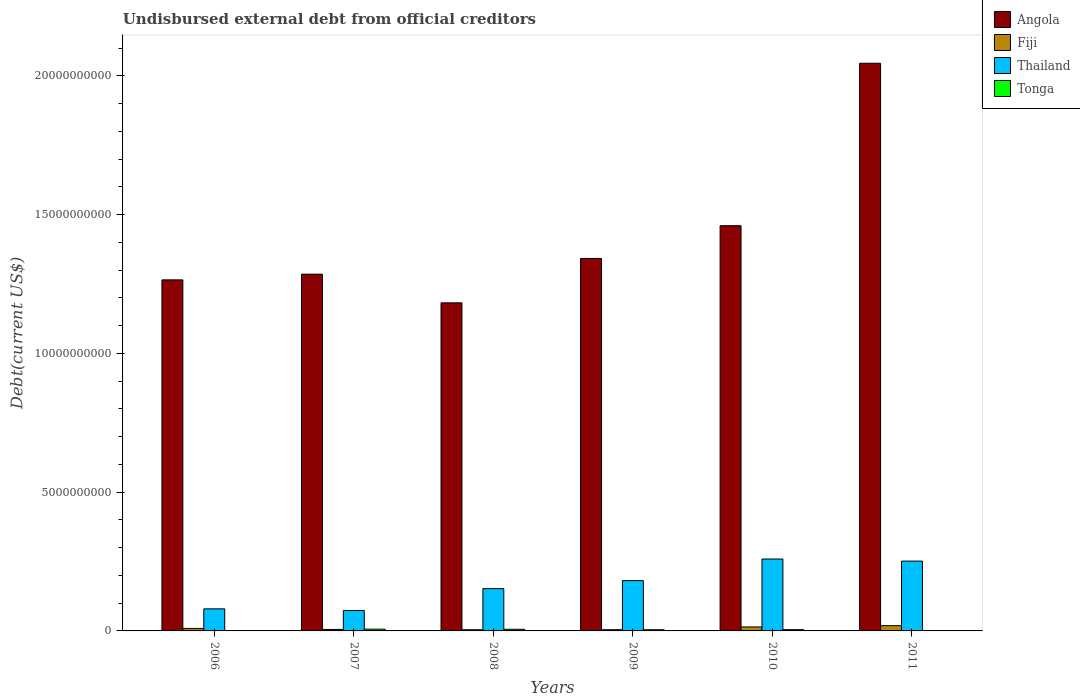How many different coloured bars are there?
Keep it short and to the point. 4. Are the number of bars per tick equal to the number of legend labels?
Offer a terse response. Yes. Are the number of bars on each tick of the X-axis equal?
Your response must be concise. Yes. How many bars are there on the 5th tick from the left?
Ensure brevity in your answer.  4. In how many cases, is the number of bars for a given year not equal to the number of legend labels?
Keep it short and to the point. 0. What is the total debt in Angola in 2010?
Keep it short and to the point. 1.46e+1. Across all years, what is the maximum total debt in Angola?
Your answer should be compact. 2.05e+1. Across all years, what is the minimum total debt in Fiji?
Offer a terse response. 4.18e+07. What is the total total debt in Angola in the graph?
Your answer should be compact. 8.58e+1. What is the difference between the total debt in Fiji in 2006 and that in 2007?
Keep it short and to the point. 3.64e+07. What is the difference between the total debt in Tonga in 2008 and the total debt in Angola in 2009?
Provide a succinct answer. -1.34e+1. What is the average total debt in Fiji per year?
Give a very brief answer. 9.39e+07. In the year 2007, what is the difference between the total debt in Fiji and total debt in Angola?
Provide a succinct answer. -1.28e+1. In how many years, is the total debt in Angola greater than 2000000000 US$?
Your answer should be very brief. 6. What is the ratio of the total debt in Tonga in 2006 to that in 2008?
Provide a succinct answer. 0.14. Is the total debt in Tonga in 2006 less than that in 2008?
Offer a very short reply. Yes. Is the difference between the total debt in Fiji in 2006 and 2011 greater than the difference between the total debt in Angola in 2006 and 2011?
Ensure brevity in your answer.  Yes. What is the difference between the highest and the second highest total debt in Tonga?
Give a very brief answer. 5.24e+06. What is the difference between the highest and the lowest total debt in Tonga?
Offer a terse response. 5.61e+07. In how many years, is the total debt in Thailand greater than the average total debt in Thailand taken over all years?
Your answer should be very brief. 3. What does the 1st bar from the left in 2007 represents?
Make the answer very short. Angola. What does the 3rd bar from the right in 2007 represents?
Offer a very short reply. Fiji. How many bars are there?
Your answer should be compact. 24. Are all the bars in the graph horizontal?
Give a very brief answer. No. How many years are there in the graph?
Keep it short and to the point. 6. Does the graph contain any zero values?
Make the answer very short. No. Does the graph contain grids?
Your answer should be compact. No. What is the title of the graph?
Make the answer very short. Undisbursed external debt from official creditors. Does "Heavily indebted poor countries" appear as one of the legend labels in the graph?
Give a very brief answer. No. What is the label or title of the X-axis?
Your response must be concise. Years. What is the label or title of the Y-axis?
Give a very brief answer. Debt(current US$). What is the Debt(current US$) of Angola in 2006?
Your answer should be very brief. 1.27e+1. What is the Debt(current US$) in Fiji in 2006?
Offer a very short reply. 9.00e+07. What is the Debt(current US$) in Thailand in 2006?
Provide a succinct answer. 7.96e+08. What is the Debt(current US$) of Tonga in 2006?
Offer a terse response. 8.28e+06. What is the Debt(current US$) in Angola in 2007?
Your answer should be very brief. 1.29e+1. What is the Debt(current US$) in Fiji in 2007?
Offer a terse response. 5.36e+07. What is the Debt(current US$) in Thailand in 2007?
Your answer should be very brief. 7.37e+08. What is the Debt(current US$) of Tonga in 2007?
Make the answer very short. 6.43e+07. What is the Debt(current US$) of Angola in 2008?
Provide a succinct answer. 1.18e+1. What is the Debt(current US$) of Fiji in 2008?
Your answer should be very brief. 4.18e+07. What is the Debt(current US$) of Thailand in 2008?
Your response must be concise. 1.52e+09. What is the Debt(current US$) of Tonga in 2008?
Your answer should be compact. 5.91e+07. What is the Debt(current US$) in Angola in 2009?
Provide a short and direct response. 1.34e+1. What is the Debt(current US$) in Fiji in 2009?
Give a very brief answer. 4.44e+07. What is the Debt(current US$) of Thailand in 2009?
Provide a succinct answer. 1.81e+09. What is the Debt(current US$) in Tonga in 2009?
Make the answer very short. 4.25e+07. What is the Debt(current US$) of Angola in 2010?
Your response must be concise. 1.46e+1. What is the Debt(current US$) of Fiji in 2010?
Keep it short and to the point. 1.44e+08. What is the Debt(current US$) in Thailand in 2010?
Your answer should be compact. 2.59e+09. What is the Debt(current US$) of Tonga in 2010?
Keep it short and to the point. 4.62e+07. What is the Debt(current US$) in Angola in 2011?
Your answer should be compact. 2.05e+1. What is the Debt(current US$) in Fiji in 2011?
Give a very brief answer. 1.90e+08. What is the Debt(current US$) in Thailand in 2011?
Offer a terse response. 2.52e+09. What is the Debt(current US$) in Tonga in 2011?
Ensure brevity in your answer.  1.12e+07. Across all years, what is the maximum Debt(current US$) in Angola?
Your answer should be very brief. 2.05e+1. Across all years, what is the maximum Debt(current US$) in Fiji?
Provide a short and direct response. 1.90e+08. Across all years, what is the maximum Debt(current US$) of Thailand?
Ensure brevity in your answer.  2.59e+09. Across all years, what is the maximum Debt(current US$) of Tonga?
Provide a succinct answer. 6.43e+07. Across all years, what is the minimum Debt(current US$) in Angola?
Your response must be concise. 1.18e+1. Across all years, what is the minimum Debt(current US$) in Fiji?
Provide a succinct answer. 4.18e+07. Across all years, what is the minimum Debt(current US$) in Thailand?
Your answer should be compact. 7.37e+08. Across all years, what is the minimum Debt(current US$) of Tonga?
Your answer should be very brief. 8.28e+06. What is the total Debt(current US$) in Angola in the graph?
Offer a very short reply. 8.58e+1. What is the total Debt(current US$) of Fiji in the graph?
Offer a terse response. 5.63e+08. What is the total Debt(current US$) in Thailand in the graph?
Keep it short and to the point. 9.98e+09. What is the total Debt(current US$) in Tonga in the graph?
Your answer should be very brief. 2.32e+08. What is the difference between the Debt(current US$) of Angola in 2006 and that in 2007?
Your answer should be very brief. -2.05e+08. What is the difference between the Debt(current US$) in Fiji in 2006 and that in 2007?
Provide a short and direct response. 3.64e+07. What is the difference between the Debt(current US$) in Thailand in 2006 and that in 2007?
Your response must be concise. 5.87e+07. What is the difference between the Debt(current US$) of Tonga in 2006 and that in 2007?
Make the answer very short. -5.61e+07. What is the difference between the Debt(current US$) of Angola in 2006 and that in 2008?
Provide a succinct answer. 8.28e+08. What is the difference between the Debt(current US$) in Fiji in 2006 and that in 2008?
Your answer should be very brief. 4.82e+07. What is the difference between the Debt(current US$) of Thailand in 2006 and that in 2008?
Provide a succinct answer. -7.29e+08. What is the difference between the Debt(current US$) in Tonga in 2006 and that in 2008?
Offer a very short reply. -5.08e+07. What is the difference between the Debt(current US$) in Angola in 2006 and that in 2009?
Your answer should be compact. -7.71e+08. What is the difference between the Debt(current US$) in Fiji in 2006 and that in 2009?
Make the answer very short. 4.56e+07. What is the difference between the Debt(current US$) of Thailand in 2006 and that in 2009?
Offer a terse response. -1.02e+09. What is the difference between the Debt(current US$) in Tonga in 2006 and that in 2009?
Your answer should be very brief. -3.42e+07. What is the difference between the Debt(current US$) in Angola in 2006 and that in 2010?
Keep it short and to the point. -1.95e+09. What is the difference between the Debt(current US$) of Fiji in 2006 and that in 2010?
Ensure brevity in your answer.  -5.38e+07. What is the difference between the Debt(current US$) in Thailand in 2006 and that in 2010?
Offer a terse response. -1.80e+09. What is the difference between the Debt(current US$) in Tonga in 2006 and that in 2010?
Give a very brief answer. -3.79e+07. What is the difference between the Debt(current US$) of Angola in 2006 and that in 2011?
Offer a very short reply. -7.81e+09. What is the difference between the Debt(current US$) in Fiji in 2006 and that in 2011?
Ensure brevity in your answer.  -9.98e+07. What is the difference between the Debt(current US$) of Thailand in 2006 and that in 2011?
Make the answer very short. -1.72e+09. What is the difference between the Debt(current US$) of Tonga in 2006 and that in 2011?
Give a very brief answer. -2.92e+06. What is the difference between the Debt(current US$) of Angola in 2007 and that in 2008?
Give a very brief answer. 1.03e+09. What is the difference between the Debt(current US$) of Fiji in 2007 and that in 2008?
Provide a succinct answer. 1.18e+07. What is the difference between the Debt(current US$) in Thailand in 2007 and that in 2008?
Offer a very short reply. -7.87e+08. What is the difference between the Debt(current US$) in Tonga in 2007 and that in 2008?
Provide a succinct answer. 5.24e+06. What is the difference between the Debt(current US$) in Angola in 2007 and that in 2009?
Keep it short and to the point. -5.66e+08. What is the difference between the Debt(current US$) of Fiji in 2007 and that in 2009?
Offer a very short reply. 9.20e+06. What is the difference between the Debt(current US$) in Thailand in 2007 and that in 2009?
Your answer should be compact. -1.08e+09. What is the difference between the Debt(current US$) of Tonga in 2007 and that in 2009?
Give a very brief answer. 2.18e+07. What is the difference between the Debt(current US$) in Angola in 2007 and that in 2010?
Provide a succinct answer. -1.75e+09. What is the difference between the Debt(current US$) in Fiji in 2007 and that in 2010?
Offer a terse response. -9.02e+07. What is the difference between the Debt(current US$) of Thailand in 2007 and that in 2010?
Your response must be concise. -1.85e+09. What is the difference between the Debt(current US$) in Tonga in 2007 and that in 2010?
Give a very brief answer. 1.81e+07. What is the difference between the Debt(current US$) of Angola in 2007 and that in 2011?
Give a very brief answer. -7.60e+09. What is the difference between the Debt(current US$) in Fiji in 2007 and that in 2011?
Keep it short and to the point. -1.36e+08. What is the difference between the Debt(current US$) in Thailand in 2007 and that in 2011?
Offer a very short reply. -1.78e+09. What is the difference between the Debt(current US$) of Tonga in 2007 and that in 2011?
Provide a short and direct response. 5.31e+07. What is the difference between the Debt(current US$) in Angola in 2008 and that in 2009?
Provide a short and direct response. -1.60e+09. What is the difference between the Debt(current US$) in Fiji in 2008 and that in 2009?
Offer a very short reply. -2.61e+06. What is the difference between the Debt(current US$) in Thailand in 2008 and that in 2009?
Provide a succinct answer. -2.89e+08. What is the difference between the Debt(current US$) in Tonga in 2008 and that in 2009?
Provide a short and direct response. 1.66e+07. What is the difference between the Debt(current US$) in Angola in 2008 and that in 2010?
Offer a very short reply. -2.78e+09. What is the difference between the Debt(current US$) of Fiji in 2008 and that in 2010?
Your answer should be very brief. -1.02e+08. What is the difference between the Debt(current US$) in Thailand in 2008 and that in 2010?
Offer a very short reply. -1.07e+09. What is the difference between the Debt(current US$) of Tonga in 2008 and that in 2010?
Your answer should be compact. 1.29e+07. What is the difference between the Debt(current US$) in Angola in 2008 and that in 2011?
Keep it short and to the point. -8.63e+09. What is the difference between the Debt(current US$) in Fiji in 2008 and that in 2011?
Provide a succinct answer. -1.48e+08. What is the difference between the Debt(current US$) of Thailand in 2008 and that in 2011?
Offer a very short reply. -9.92e+08. What is the difference between the Debt(current US$) in Tonga in 2008 and that in 2011?
Provide a short and direct response. 4.79e+07. What is the difference between the Debt(current US$) in Angola in 2009 and that in 2010?
Ensure brevity in your answer.  -1.18e+09. What is the difference between the Debt(current US$) of Fiji in 2009 and that in 2010?
Ensure brevity in your answer.  -9.94e+07. What is the difference between the Debt(current US$) of Thailand in 2009 and that in 2010?
Provide a succinct answer. -7.78e+08. What is the difference between the Debt(current US$) of Tonga in 2009 and that in 2010?
Your answer should be very brief. -3.69e+06. What is the difference between the Debt(current US$) in Angola in 2009 and that in 2011?
Provide a short and direct response. -7.03e+09. What is the difference between the Debt(current US$) of Fiji in 2009 and that in 2011?
Make the answer very short. -1.45e+08. What is the difference between the Debt(current US$) in Thailand in 2009 and that in 2011?
Make the answer very short. -7.03e+08. What is the difference between the Debt(current US$) in Tonga in 2009 and that in 2011?
Your answer should be compact. 3.13e+07. What is the difference between the Debt(current US$) of Angola in 2010 and that in 2011?
Provide a short and direct response. -5.85e+09. What is the difference between the Debt(current US$) in Fiji in 2010 and that in 2011?
Your response must be concise. -4.60e+07. What is the difference between the Debt(current US$) in Thailand in 2010 and that in 2011?
Your response must be concise. 7.56e+07. What is the difference between the Debt(current US$) in Tonga in 2010 and that in 2011?
Your answer should be compact. 3.50e+07. What is the difference between the Debt(current US$) of Angola in 2006 and the Debt(current US$) of Fiji in 2007?
Your answer should be compact. 1.26e+1. What is the difference between the Debt(current US$) in Angola in 2006 and the Debt(current US$) in Thailand in 2007?
Keep it short and to the point. 1.19e+1. What is the difference between the Debt(current US$) of Angola in 2006 and the Debt(current US$) of Tonga in 2007?
Keep it short and to the point. 1.26e+1. What is the difference between the Debt(current US$) of Fiji in 2006 and the Debt(current US$) of Thailand in 2007?
Offer a very short reply. -6.47e+08. What is the difference between the Debt(current US$) in Fiji in 2006 and the Debt(current US$) in Tonga in 2007?
Offer a terse response. 2.56e+07. What is the difference between the Debt(current US$) of Thailand in 2006 and the Debt(current US$) of Tonga in 2007?
Give a very brief answer. 7.31e+08. What is the difference between the Debt(current US$) in Angola in 2006 and the Debt(current US$) in Fiji in 2008?
Keep it short and to the point. 1.26e+1. What is the difference between the Debt(current US$) of Angola in 2006 and the Debt(current US$) of Thailand in 2008?
Offer a terse response. 1.11e+1. What is the difference between the Debt(current US$) in Angola in 2006 and the Debt(current US$) in Tonga in 2008?
Your answer should be compact. 1.26e+1. What is the difference between the Debt(current US$) of Fiji in 2006 and the Debt(current US$) of Thailand in 2008?
Keep it short and to the point. -1.43e+09. What is the difference between the Debt(current US$) in Fiji in 2006 and the Debt(current US$) in Tonga in 2008?
Provide a succinct answer. 3.09e+07. What is the difference between the Debt(current US$) in Thailand in 2006 and the Debt(current US$) in Tonga in 2008?
Provide a short and direct response. 7.36e+08. What is the difference between the Debt(current US$) in Angola in 2006 and the Debt(current US$) in Fiji in 2009?
Provide a short and direct response. 1.26e+1. What is the difference between the Debt(current US$) in Angola in 2006 and the Debt(current US$) in Thailand in 2009?
Give a very brief answer. 1.08e+1. What is the difference between the Debt(current US$) of Angola in 2006 and the Debt(current US$) of Tonga in 2009?
Keep it short and to the point. 1.26e+1. What is the difference between the Debt(current US$) of Fiji in 2006 and the Debt(current US$) of Thailand in 2009?
Ensure brevity in your answer.  -1.72e+09. What is the difference between the Debt(current US$) of Fiji in 2006 and the Debt(current US$) of Tonga in 2009?
Offer a terse response. 4.75e+07. What is the difference between the Debt(current US$) in Thailand in 2006 and the Debt(current US$) in Tonga in 2009?
Offer a terse response. 7.53e+08. What is the difference between the Debt(current US$) in Angola in 2006 and the Debt(current US$) in Fiji in 2010?
Offer a very short reply. 1.25e+1. What is the difference between the Debt(current US$) in Angola in 2006 and the Debt(current US$) in Thailand in 2010?
Ensure brevity in your answer.  1.01e+1. What is the difference between the Debt(current US$) in Angola in 2006 and the Debt(current US$) in Tonga in 2010?
Give a very brief answer. 1.26e+1. What is the difference between the Debt(current US$) in Fiji in 2006 and the Debt(current US$) in Thailand in 2010?
Give a very brief answer. -2.50e+09. What is the difference between the Debt(current US$) of Fiji in 2006 and the Debt(current US$) of Tonga in 2010?
Offer a terse response. 4.38e+07. What is the difference between the Debt(current US$) in Thailand in 2006 and the Debt(current US$) in Tonga in 2010?
Provide a short and direct response. 7.49e+08. What is the difference between the Debt(current US$) in Angola in 2006 and the Debt(current US$) in Fiji in 2011?
Offer a terse response. 1.25e+1. What is the difference between the Debt(current US$) in Angola in 2006 and the Debt(current US$) in Thailand in 2011?
Provide a short and direct response. 1.01e+1. What is the difference between the Debt(current US$) in Angola in 2006 and the Debt(current US$) in Tonga in 2011?
Offer a very short reply. 1.26e+1. What is the difference between the Debt(current US$) of Fiji in 2006 and the Debt(current US$) of Thailand in 2011?
Provide a short and direct response. -2.43e+09. What is the difference between the Debt(current US$) in Fiji in 2006 and the Debt(current US$) in Tonga in 2011?
Keep it short and to the point. 7.88e+07. What is the difference between the Debt(current US$) in Thailand in 2006 and the Debt(current US$) in Tonga in 2011?
Make the answer very short. 7.84e+08. What is the difference between the Debt(current US$) in Angola in 2007 and the Debt(current US$) in Fiji in 2008?
Your answer should be very brief. 1.28e+1. What is the difference between the Debt(current US$) of Angola in 2007 and the Debt(current US$) of Thailand in 2008?
Make the answer very short. 1.13e+1. What is the difference between the Debt(current US$) in Angola in 2007 and the Debt(current US$) in Tonga in 2008?
Keep it short and to the point. 1.28e+1. What is the difference between the Debt(current US$) in Fiji in 2007 and the Debt(current US$) in Thailand in 2008?
Offer a terse response. -1.47e+09. What is the difference between the Debt(current US$) of Fiji in 2007 and the Debt(current US$) of Tonga in 2008?
Your response must be concise. -5.51e+06. What is the difference between the Debt(current US$) in Thailand in 2007 and the Debt(current US$) in Tonga in 2008?
Provide a succinct answer. 6.78e+08. What is the difference between the Debt(current US$) of Angola in 2007 and the Debt(current US$) of Fiji in 2009?
Offer a very short reply. 1.28e+1. What is the difference between the Debt(current US$) in Angola in 2007 and the Debt(current US$) in Thailand in 2009?
Ensure brevity in your answer.  1.10e+1. What is the difference between the Debt(current US$) of Angola in 2007 and the Debt(current US$) of Tonga in 2009?
Your response must be concise. 1.28e+1. What is the difference between the Debt(current US$) of Fiji in 2007 and the Debt(current US$) of Thailand in 2009?
Provide a succinct answer. -1.76e+09. What is the difference between the Debt(current US$) of Fiji in 2007 and the Debt(current US$) of Tonga in 2009?
Keep it short and to the point. 1.11e+07. What is the difference between the Debt(current US$) in Thailand in 2007 and the Debt(current US$) in Tonga in 2009?
Your response must be concise. 6.94e+08. What is the difference between the Debt(current US$) in Angola in 2007 and the Debt(current US$) in Fiji in 2010?
Your answer should be very brief. 1.27e+1. What is the difference between the Debt(current US$) in Angola in 2007 and the Debt(current US$) in Thailand in 2010?
Give a very brief answer. 1.03e+1. What is the difference between the Debt(current US$) of Angola in 2007 and the Debt(current US$) of Tonga in 2010?
Your response must be concise. 1.28e+1. What is the difference between the Debt(current US$) of Fiji in 2007 and the Debt(current US$) of Thailand in 2010?
Give a very brief answer. -2.54e+09. What is the difference between the Debt(current US$) of Fiji in 2007 and the Debt(current US$) of Tonga in 2010?
Provide a succinct answer. 7.37e+06. What is the difference between the Debt(current US$) in Thailand in 2007 and the Debt(current US$) in Tonga in 2010?
Keep it short and to the point. 6.91e+08. What is the difference between the Debt(current US$) of Angola in 2007 and the Debt(current US$) of Fiji in 2011?
Your answer should be very brief. 1.27e+1. What is the difference between the Debt(current US$) in Angola in 2007 and the Debt(current US$) in Thailand in 2011?
Provide a succinct answer. 1.03e+1. What is the difference between the Debt(current US$) in Angola in 2007 and the Debt(current US$) in Tonga in 2011?
Offer a very short reply. 1.28e+1. What is the difference between the Debt(current US$) of Fiji in 2007 and the Debt(current US$) of Thailand in 2011?
Provide a succinct answer. -2.46e+09. What is the difference between the Debt(current US$) in Fiji in 2007 and the Debt(current US$) in Tonga in 2011?
Provide a succinct answer. 4.24e+07. What is the difference between the Debt(current US$) in Thailand in 2007 and the Debt(current US$) in Tonga in 2011?
Ensure brevity in your answer.  7.26e+08. What is the difference between the Debt(current US$) of Angola in 2008 and the Debt(current US$) of Fiji in 2009?
Offer a very short reply. 1.18e+1. What is the difference between the Debt(current US$) in Angola in 2008 and the Debt(current US$) in Thailand in 2009?
Ensure brevity in your answer.  1.00e+1. What is the difference between the Debt(current US$) of Angola in 2008 and the Debt(current US$) of Tonga in 2009?
Ensure brevity in your answer.  1.18e+1. What is the difference between the Debt(current US$) in Fiji in 2008 and the Debt(current US$) in Thailand in 2009?
Keep it short and to the point. -1.77e+09. What is the difference between the Debt(current US$) in Fiji in 2008 and the Debt(current US$) in Tonga in 2009?
Your answer should be compact. -7.49e+05. What is the difference between the Debt(current US$) of Thailand in 2008 and the Debt(current US$) of Tonga in 2009?
Keep it short and to the point. 1.48e+09. What is the difference between the Debt(current US$) of Angola in 2008 and the Debt(current US$) of Fiji in 2010?
Offer a very short reply. 1.17e+1. What is the difference between the Debt(current US$) in Angola in 2008 and the Debt(current US$) in Thailand in 2010?
Keep it short and to the point. 9.23e+09. What is the difference between the Debt(current US$) of Angola in 2008 and the Debt(current US$) of Tonga in 2010?
Make the answer very short. 1.18e+1. What is the difference between the Debt(current US$) of Fiji in 2008 and the Debt(current US$) of Thailand in 2010?
Your answer should be compact. -2.55e+09. What is the difference between the Debt(current US$) in Fiji in 2008 and the Debt(current US$) in Tonga in 2010?
Give a very brief answer. -4.44e+06. What is the difference between the Debt(current US$) in Thailand in 2008 and the Debt(current US$) in Tonga in 2010?
Keep it short and to the point. 1.48e+09. What is the difference between the Debt(current US$) in Angola in 2008 and the Debt(current US$) in Fiji in 2011?
Your answer should be very brief. 1.16e+1. What is the difference between the Debt(current US$) in Angola in 2008 and the Debt(current US$) in Thailand in 2011?
Offer a very short reply. 9.31e+09. What is the difference between the Debt(current US$) in Angola in 2008 and the Debt(current US$) in Tonga in 2011?
Ensure brevity in your answer.  1.18e+1. What is the difference between the Debt(current US$) in Fiji in 2008 and the Debt(current US$) in Thailand in 2011?
Your answer should be compact. -2.47e+09. What is the difference between the Debt(current US$) in Fiji in 2008 and the Debt(current US$) in Tonga in 2011?
Offer a terse response. 3.06e+07. What is the difference between the Debt(current US$) in Thailand in 2008 and the Debt(current US$) in Tonga in 2011?
Give a very brief answer. 1.51e+09. What is the difference between the Debt(current US$) of Angola in 2009 and the Debt(current US$) of Fiji in 2010?
Offer a terse response. 1.33e+1. What is the difference between the Debt(current US$) in Angola in 2009 and the Debt(current US$) in Thailand in 2010?
Offer a terse response. 1.08e+1. What is the difference between the Debt(current US$) of Angola in 2009 and the Debt(current US$) of Tonga in 2010?
Your answer should be very brief. 1.34e+1. What is the difference between the Debt(current US$) in Fiji in 2009 and the Debt(current US$) in Thailand in 2010?
Ensure brevity in your answer.  -2.55e+09. What is the difference between the Debt(current US$) in Fiji in 2009 and the Debt(current US$) in Tonga in 2010?
Ensure brevity in your answer.  -1.83e+06. What is the difference between the Debt(current US$) in Thailand in 2009 and the Debt(current US$) in Tonga in 2010?
Your answer should be compact. 1.77e+09. What is the difference between the Debt(current US$) in Angola in 2009 and the Debt(current US$) in Fiji in 2011?
Your response must be concise. 1.32e+1. What is the difference between the Debt(current US$) of Angola in 2009 and the Debt(current US$) of Thailand in 2011?
Ensure brevity in your answer.  1.09e+1. What is the difference between the Debt(current US$) in Angola in 2009 and the Debt(current US$) in Tonga in 2011?
Offer a very short reply. 1.34e+1. What is the difference between the Debt(current US$) of Fiji in 2009 and the Debt(current US$) of Thailand in 2011?
Provide a short and direct response. -2.47e+09. What is the difference between the Debt(current US$) in Fiji in 2009 and the Debt(current US$) in Tonga in 2011?
Ensure brevity in your answer.  3.32e+07. What is the difference between the Debt(current US$) of Thailand in 2009 and the Debt(current US$) of Tonga in 2011?
Your answer should be very brief. 1.80e+09. What is the difference between the Debt(current US$) in Angola in 2010 and the Debt(current US$) in Fiji in 2011?
Ensure brevity in your answer.  1.44e+1. What is the difference between the Debt(current US$) of Angola in 2010 and the Debt(current US$) of Thailand in 2011?
Give a very brief answer. 1.21e+1. What is the difference between the Debt(current US$) in Angola in 2010 and the Debt(current US$) in Tonga in 2011?
Make the answer very short. 1.46e+1. What is the difference between the Debt(current US$) of Fiji in 2010 and the Debt(current US$) of Thailand in 2011?
Offer a terse response. -2.37e+09. What is the difference between the Debt(current US$) in Fiji in 2010 and the Debt(current US$) in Tonga in 2011?
Give a very brief answer. 1.33e+08. What is the difference between the Debt(current US$) of Thailand in 2010 and the Debt(current US$) of Tonga in 2011?
Your answer should be compact. 2.58e+09. What is the average Debt(current US$) of Angola per year?
Make the answer very short. 1.43e+1. What is the average Debt(current US$) in Fiji per year?
Provide a succinct answer. 9.39e+07. What is the average Debt(current US$) of Thailand per year?
Provide a short and direct response. 1.66e+09. What is the average Debt(current US$) of Tonga per year?
Your answer should be very brief. 3.86e+07. In the year 2006, what is the difference between the Debt(current US$) in Angola and Debt(current US$) in Fiji?
Offer a very short reply. 1.26e+1. In the year 2006, what is the difference between the Debt(current US$) of Angola and Debt(current US$) of Thailand?
Make the answer very short. 1.19e+1. In the year 2006, what is the difference between the Debt(current US$) in Angola and Debt(current US$) in Tonga?
Your response must be concise. 1.26e+1. In the year 2006, what is the difference between the Debt(current US$) in Fiji and Debt(current US$) in Thailand?
Ensure brevity in your answer.  -7.06e+08. In the year 2006, what is the difference between the Debt(current US$) of Fiji and Debt(current US$) of Tonga?
Your response must be concise. 8.17e+07. In the year 2006, what is the difference between the Debt(current US$) in Thailand and Debt(current US$) in Tonga?
Your answer should be compact. 7.87e+08. In the year 2007, what is the difference between the Debt(current US$) in Angola and Debt(current US$) in Fiji?
Provide a succinct answer. 1.28e+1. In the year 2007, what is the difference between the Debt(current US$) of Angola and Debt(current US$) of Thailand?
Ensure brevity in your answer.  1.21e+1. In the year 2007, what is the difference between the Debt(current US$) in Angola and Debt(current US$) in Tonga?
Provide a succinct answer. 1.28e+1. In the year 2007, what is the difference between the Debt(current US$) in Fiji and Debt(current US$) in Thailand?
Your response must be concise. -6.83e+08. In the year 2007, what is the difference between the Debt(current US$) in Fiji and Debt(current US$) in Tonga?
Provide a succinct answer. -1.08e+07. In the year 2007, what is the difference between the Debt(current US$) of Thailand and Debt(current US$) of Tonga?
Your response must be concise. 6.73e+08. In the year 2008, what is the difference between the Debt(current US$) of Angola and Debt(current US$) of Fiji?
Make the answer very short. 1.18e+1. In the year 2008, what is the difference between the Debt(current US$) of Angola and Debt(current US$) of Thailand?
Provide a succinct answer. 1.03e+1. In the year 2008, what is the difference between the Debt(current US$) of Angola and Debt(current US$) of Tonga?
Offer a very short reply. 1.18e+1. In the year 2008, what is the difference between the Debt(current US$) of Fiji and Debt(current US$) of Thailand?
Offer a terse response. -1.48e+09. In the year 2008, what is the difference between the Debt(current US$) of Fiji and Debt(current US$) of Tonga?
Provide a short and direct response. -1.73e+07. In the year 2008, what is the difference between the Debt(current US$) of Thailand and Debt(current US$) of Tonga?
Offer a terse response. 1.47e+09. In the year 2009, what is the difference between the Debt(current US$) in Angola and Debt(current US$) in Fiji?
Provide a succinct answer. 1.34e+1. In the year 2009, what is the difference between the Debt(current US$) in Angola and Debt(current US$) in Thailand?
Your answer should be compact. 1.16e+1. In the year 2009, what is the difference between the Debt(current US$) in Angola and Debt(current US$) in Tonga?
Your answer should be very brief. 1.34e+1. In the year 2009, what is the difference between the Debt(current US$) in Fiji and Debt(current US$) in Thailand?
Provide a succinct answer. -1.77e+09. In the year 2009, what is the difference between the Debt(current US$) of Fiji and Debt(current US$) of Tonga?
Provide a short and direct response. 1.86e+06. In the year 2009, what is the difference between the Debt(current US$) of Thailand and Debt(current US$) of Tonga?
Provide a succinct answer. 1.77e+09. In the year 2010, what is the difference between the Debt(current US$) of Angola and Debt(current US$) of Fiji?
Give a very brief answer. 1.45e+1. In the year 2010, what is the difference between the Debt(current US$) of Angola and Debt(current US$) of Thailand?
Provide a short and direct response. 1.20e+1. In the year 2010, what is the difference between the Debt(current US$) of Angola and Debt(current US$) of Tonga?
Make the answer very short. 1.46e+1. In the year 2010, what is the difference between the Debt(current US$) in Fiji and Debt(current US$) in Thailand?
Keep it short and to the point. -2.45e+09. In the year 2010, what is the difference between the Debt(current US$) of Fiji and Debt(current US$) of Tonga?
Provide a short and direct response. 9.76e+07. In the year 2010, what is the difference between the Debt(current US$) in Thailand and Debt(current US$) in Tonga?
Your response must be concise. 2.55e+09. In the year 2011, what is the difference between the Debt(current US$) in Angola and Debt(current US$) in Fiji?
Provide a short and direct response. 2.03e+1. In the year 2011, what is the difference between the Debt(current US$) in Angola and Debt(current US$) in Thailand?
Offer a very short reply. 1.79e+1. In the year 2011, what is the difference between the Debt(current US$) in Angola and Debt(current US$) in Tonga?
Provide a short and direct response. 2.04e+1. In the year 2011, what is the difference between the Debt(current US$) of Fiji and Debt(current US$) of Thailand?
Provide a succinct answer. -2.33e+09. In the year 2011, what is the difference between the Debt(current US$) in Fiji and Debt(current US$) in Tonga?
Make the answer very short. 1.79e+08. In the year 2011, what is the difference between the Debt(current US$) of Thailand and Debt(current US$) of Tonga?
Your answer should be very brief. 2.50e+09. What is the ratio of the Debt(current US$) in Fiji in 2006 to that in 2007?
Your answer should be compact. 1.68. What is the ratio of the Debt(current US$) of Thailand in 2006 to that in 2007?
Your answer should be very brief. 1.08. What is the ratio of the Debt(current US$) in Tonga in 2006 to that in 2007?
Make the answer very short. 0.13. What is the ratio of the Debt(current US$) in Angola in 2006 to that in 2008?
Keep it short and to the point. 1.07. What is the ratio of the Debt(current US$) in Fiji in 2006 to that in 2008?
Your answer should be compact. 2.15. What is the ratio of the Debt(current US$) of Thailand in 2006 to that in 2008?
Offer a terse response. 0.52. What is the ratio of the Debt(current US$) in Tonga in 2006 to that in 2008?
Ensure brevity in your answer.  0.14. What is the ratio of the Debt(current US$) of Angola in 2006 to that in 2009?
Offer a terse response. 0.94. What is the ratio of the Debt(current US$) of Fiji in 2006 to that in 2009?
Make the answer very short. 2.03. What is the ratio of the Debt(current US$) in Thailand in 2006 to that in 2009?
Your response must be concise. 0.44. What is the ratio of the Debt(current US$) in Tonga in 2006 to that in 2009?
Your answer should be compact. 0.19. What is the ratio of the Debt(current US$) in Angola in 2006 to that in 2010?
Your answer should be compact. 0.87. What is the ratio of the Debt(current US$) of Fiji in 2006 to that in 2010?
Your answer should be compact. 0.63. What is the ratio of the Debt(current US$) in Thailand in 2006 to that in 2010?
Offer a terse response. 0.31. What is the ratio of the Debt(current US$) in Tonga in 2006 to that in 2010?
Make the answer very short. 0.18. What is the ratio of the Debt(current US$) of Angola in 2006 to that in 2011?
Ensure brevity in your answer.  0.62. What is the ratio of the Debt(current US$) in Fiji in 2006 to that in 2011?
Offer a very short reply. 0.47. What is the ratio of the Debt(current US$) of Thailand in 2006 to that in 2011?
Provide a succinct answer. 0.32. What is the ratio of the Debt(current US$) in Tonga in 2006 to that in 2011?
Ensure brevity in your answer.  0.74. What is the ratio of the Debt(current US$) of Angola in 2007 to that in 2008?
Ensure brevity in your answer.  1.09. What is the ratio of the Debt(current US$) in Fiji in 2007 to that in 2008?
Provide a short and direct response. 1.28. What is the ratio of the Debt(current US$) in Thailand in 2007 to that in 2008?
Make the answer very short. 0.48. What is the ratio of the Debt(current US$) of Tonga in 2007 to that in 2008?
Keep it short and to the point. 1.09. What is the ratio of the Debt(current US$) of Angola in 2007 to that in 2009?
Provide a succinct answer. 0.96. What is the ratio of the Debt(current US$) of Fiji in 2007 to that in 2009?
Make the answer very short. 1.21. What is the ratio of the Debt(current US$) of Thailand in 2007 to that in 2009?
Offer a terse response. 0.41. What is the ratio of the Debt(current US$) in Tonga in 2007 to that in 2009?
Provide a short and direct response. 1.51. What is the ratio of the Debt(current US$) in Angola in 2007 to that in 2010?
Keep it short and to the point. 0.88. What is the ratio of the Debt(current US$) in Fiji in 2007 to that in 2010?
Provide a succinct answer. 0.37. What is the ratio of the Debt(current US$) of Thailand in 2007 to that in 2010?
Provide a succinct answer. 0.28. What is the ratio of the Debt(current US$) in Tonga in 2007 to that in 2010?
Ensure brevity in your answer.  1.39. What is the ratio of the Debt(current US$) of Angola in 2007 to that in 2011?
Offer a very short reply. 0.63. What is the ratio of the Debt(current US$) of Fiji in 2007 to that in 2011?
Your answer should be very brief. 0.28. What is the ratio of the Debt(current US$) in Thailand in 2007 to that in 2011?
Your answer should be compact. 0.29. What is the ratio of the Debt(current US$) in Tonga in 2007 to that in 2011?
Offer a very short reply. 5.75. What is the ratio of the Debt(current US$) of Angola in 2008 to that in 2009?
Offer a terse response. 0.88. What is the ratio of the Debt(current US$) in Fiji in 2008 to that in 2009?
Provide a succinct answer. 0.94. What is the ratio of the Debt(current US$) in Thailand in 2008 to that in 2009?
Make the answer very short. 0.84. What is the ratio of the Debt(current US$) of Tonga in 2008 to that in 2009?
Ensure brevity in your answer.  1.39. What is the ratio of the Debt(current US$) in Angola in 2008 to that in 2010?
Your answer should be compact. 0.81. What is the ratio of the Debt(current US$) of Fiji in 2008 to that in 2010?
Provide a succinct answer. 0.29. What is the ratio of the Debt(current US$) of Thailand in 2008 to that in 2010?
Ensure brevity in your answer.  0.59. What is the ratio of the Debt(current US$) in Tonga in 2008 to that in 2010?
Keep it short and to the point. 1.28. What is the ratio of the Debt(current US$) of Angola in 2008 to that in 2011?
Provide a short and direct response. 0.58. What is the ratio of the Debt(current US$) of Fiji in 2008 to that in 2011?
Ensure brevity in your answer.  0.22. What is the ratio of the Debt(current US$) of Thailand in 2008 to that in 2011?
Keep it short and to the point. 0.61. What is the ratio of the Debt(current US$) in Tonga in 2008 to that in 2011?
Offer a terse response. 5.28. What is the ratio of the Debt(current US$) of Angola in 2009 to that in 2010?
Your answer should be compact. 0.92. What is the ratio of the Debt(current US$) in Fiji in 2009 to that in 2010?
Your response must be concise. 0.31. What is the ratio of the Debt(current US$) of Thailand in 2009 to that in 2010?
Ensure brevity in your answer.  0.7. What is the ratio of the Debt(current US$) in Tonga in 2009 to that in 2010?
Your response must be concise. 0.92. What is the ratio of the Debt(current US$) in Angola in 2009 to that in 2011?
Your answer should be very brief. 0.66. What is the ratio of the Debt(current US$) in Fiji in 2009 to that in 2011?
Your response must be concise. 0.23. What is the ratio of the Debt(current US$) of Thailand in 2009 to that in 2011?
Make the answer very short. 0.72. What is the ratio of the Debt(current US$) of Tonga in 2009 to that in 2011?
Your answer should be compact. 3.8. What is the ratio of the Debt(current US$) in Angola in 2010 to that in 2011?
Make the answer very short. 0.71. What is the ratio of the Debt(current US$) of Fiji in 2010 to that in 2011?
Keep it short and to the point. 0.76. What is the ratio of the Debt(current US$) of Thailand in 2010 to that in 2011?
Provide a short and direct response. 1.03. What is the ratio of the Debt(current US$) of Tonga in 2010 to that in 2011?
Provide a succinct answer. 4.13. What is the difference between the highest and the second highest Debt(current US$) of Angola?
Keep it short and to the point. 5.85e+09. What is the difference between the highest and the second highest Debt(current US$) in Fiji?
Your answer should be very brief. 4.60e+07. What is the difference between the highest and the second highest Debt(current US$) of Thailand?
Ensure brevity in your answer.  7.56e+07. What is the difference between the highest and the second highest Debt(current US$) of Tonga?
Your response must be concise. 5.24e+06. What is the difference between the highest and the lowest Debt(current US$) in Angola?
Provide a succinct answer. 8.63e+09. What is the difference between the highest and the lowest Debt(current US$) in Fiji?
Make the answer very short. 1.48e+08. What is the difference between the highest and the lowest Debt(current US$) in Thailand?
Offer a very short reply. 1.85e+09. What is the difference between the highest and the lowest Debt(current US$) in Tonga?
Your answer should be compact. 5.61e+07. 